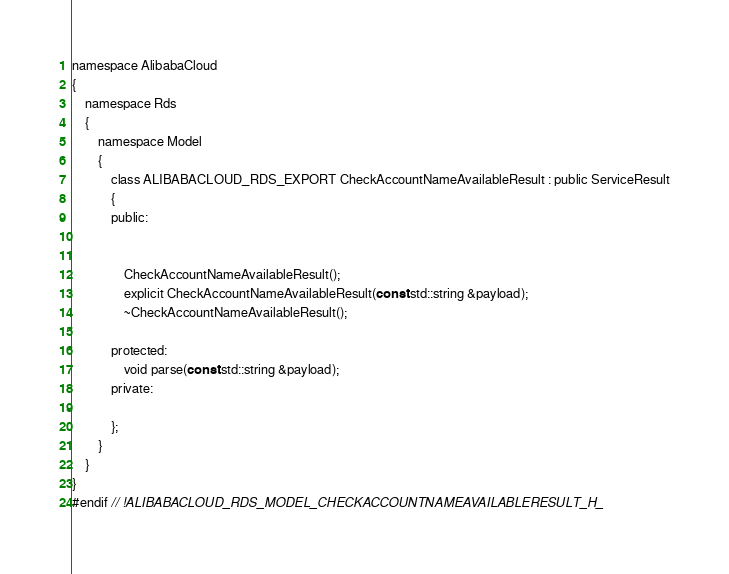Convert code to text. <code><loc_0><loc_0><loc_500><loc_500><_C_>namespace AlibabaCloud
{
	namespace Rds
	{
		namespace Model
		{
			class ALIBABACLOUD_RDS_EXPORT CheckAccountNameAvailableResult : public ServiceResult
			{
			public:


				CheckAccountNameAvailableResult();
				explicit CheckAccountNameAvailableResult(const std::string &payload);
				~CheckAccountNameAvailableResult();

			protected:
				void parse(const std::string &payload);
			private:

			};
		}
	}
}
#endif // !ALIBABACLOUD_RDS_MODEL_CHECKACCOUNTNAMEAVAILABLERESULT_H_</code> 